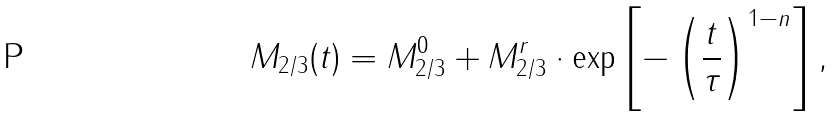<formula> <loc_0><loc_0><loc_500><loc_500>M _ { 2 / 3 } ( t ) = M _ { 2 / 3 } ^ { 0 } + M _ { 2 / 3 } ^ { r } \cdot \text {exp} \left [ - \left ( \frac { t } { \tau } \right ) ^ { 1 - n } \right ] ,</formula> 